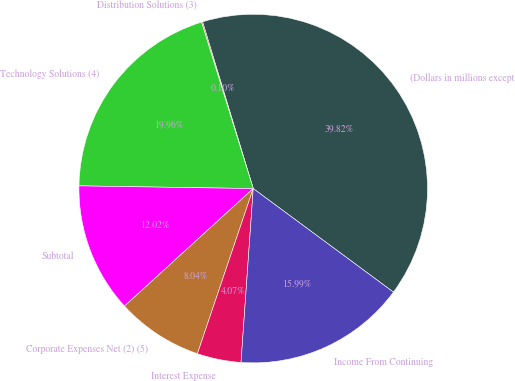<chart> <loc_0><loc_0><loc_500><loc_500><pie_chart><fcel>(Dollars in millions except<fcel>Distribution Solutions (3)<fcel>Technology Solutions (4)<fcel>Subtotal<fcel>Corporate Expenses Net (2) (5)<fcel>Interest Expense<fcel>Income From Continuing<nl><fcel>39.82%<fcel>0.1%<fcel>19.96%<fcel>12.02%<fcel>8.04%<fcel>4.07%<fcel>15.99%<nl></chart> 